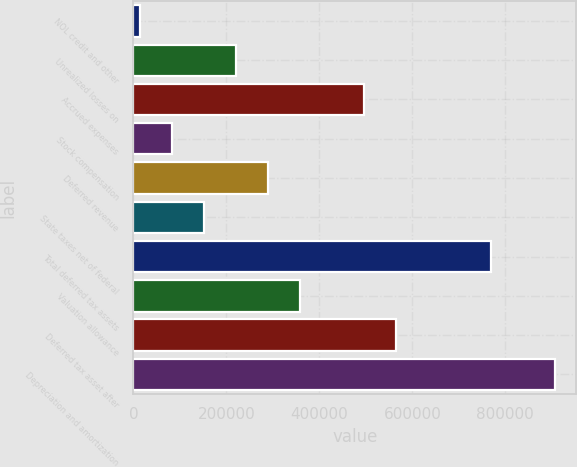<chart> <loc_0><loc_0><loc_500><loc_500><bar_chart><fcel>NOL credit and other<fcel>Unrealized losses on<fcel>Accrued expenses<fcel>Stock compensation<fcel>Deferred revenue<fcel>State taxes net of federal<fcel>Total deferred tax assets<fcel>Valuation allowance<fcel>Deferred tax asset after<fcel>Depreciation and amortization<nl><fcel>14595<fcel>220666<fcel>495426<fcel>83285.2<fcel>289356<fcel>151975<fcel>770187<fcel>358046<fcel>564117<fcel>907568<nl></chart> 